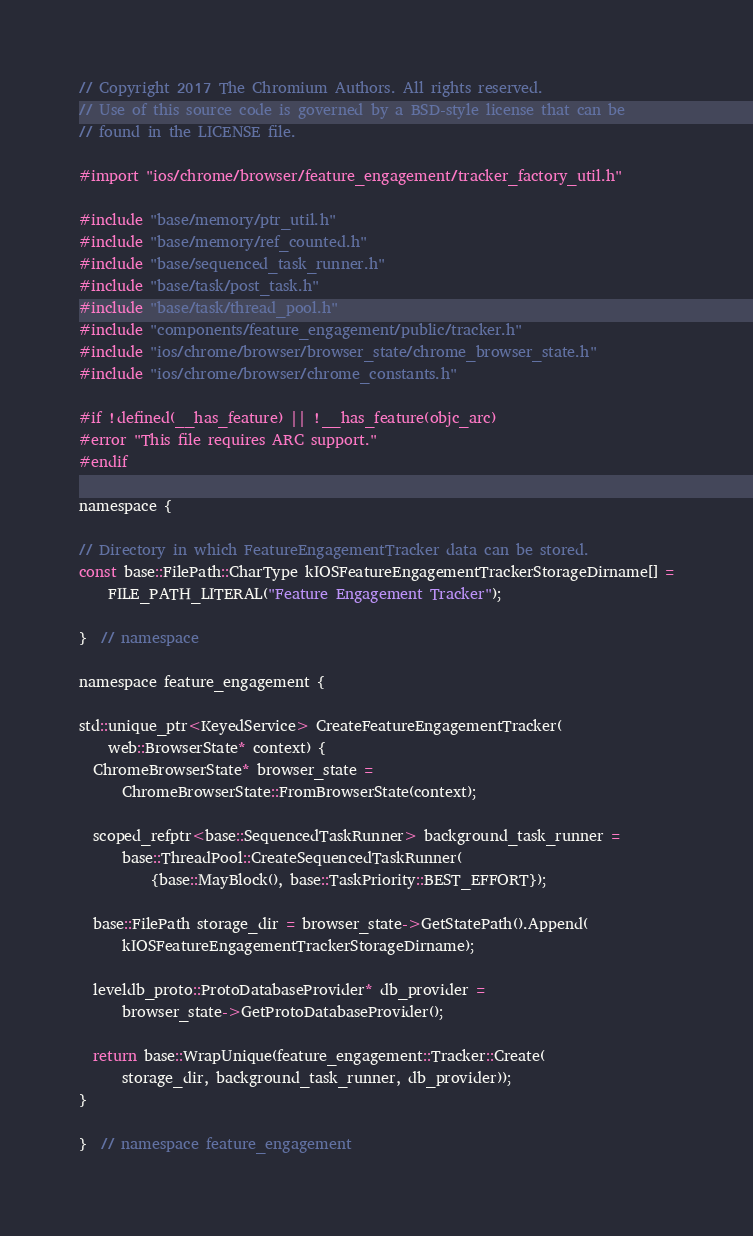Convert code to text. <code><loc_0><loc_0><loc_500><loc_500><_ObjectiveC_>// Copyright 2017 The Chromium Authors. All rights reserved.
// Use of this source code is governed by a BSD-style license that can be
// found in the LICENSE file.

#import "ios/chrome/browser/feature_engagement/tracker_factory_util.h"

#include "base/memory/ptr_util.h"
#include "base/memory/ref_counted.h"
#include "base/sequenced_task_runner.h"
#include "base/task/post_task.h"
#include "base/task/thread_pool.h"
#include "components/feature_engagement/public/tracker.h"
#include "ios/chrome/browser/browser_state/chrome_browser_state.h"
#include "ios/chrome/browser/chrome_constants.h"

#if !defined(__has_feature) || !__has_feature(objc_arc)
#error "This file requires ARC support."
#endif

namespace {

// Directory in which FeatureEngagementTracker data can be stored.
const base::FilePath::CharType kIOSFeatureEngagementTrackerStorageDirname[] =
    FILE_PATH_LITERAL("Feature Engagement Tracker");

}  // namespace

namespace feature_engagement {

std::unique_ptr<KeyedService> CreateFeatureEngagementTracker(
    web::BrowserState* context) {
  ChromeBrowserState* browser_state =
      ChromeBrowserState::FromBrowserState(context);

  scoped_refptr<base::SequencedTaskRunner> background_task_runner =
      base::ThreadPool::CreateSequencedTaskRunner(
          {base::MayBlock(), base::TaskPriority::BEST_EFFORT});

  base::FilePath storage_dir = browser_state->GetStatePath().Append(
      kIOSFeatureEngagementTrackerStorageDirname);

  leveldb_proto::ProtoDatabaseProvider* db_provider =
      browser_state->GetProtoDatabaseProvider();

  return base::WrapUnique(feature_engagement::Tracker::Create(
      storage_dir, background_task_runner, db_provider));
}

}  // namespace feature_engagement
</code> 